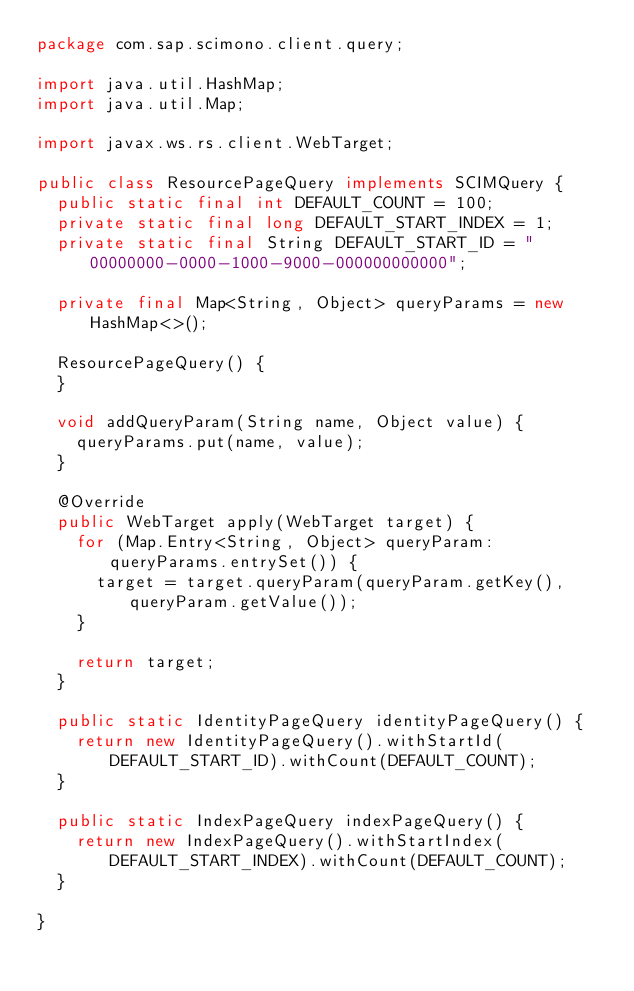<code> <loc_0><loc_0><loc_500><loc_500><_Java_>package com.sap.scimono.client.query;

import java.util.HashMap;
import java.util.Map;

import javax.ws.rs.client.WebTarget;

public class ResourcePageQuery implements SCIMQuery {
  public static final int DEFAULT_COUNT = 100;
  private static final long DEFAULT_START_INDEX = 1;
  private static final String DEFAULT_START_ID = "00000000-0000-1000-9000-000000000000";

  private final Map<String, Object> queryParams = new HashMap<>();

  ResourcePageQuery() {
  }

  void addQueryParam(String name, Object value) {
    queryParams.put(name, value);
  }

  @Override
  public WebTarget apply(WebTarget target) {
    for (Map.Entry<String, Object> queryParam: queryParams.entrySet()) {
      target = target.queryParam(queryParam.getKey(), queryParam.getValue());
    }

    return target;
  }

  public static IdentityPageQuery identityPageQuery() {
    return new IdentityPageQuery().withStartId(DEFAULT_START_ID).withCount(DEFAULT_COUNT);
  }

  public static IndexPageQuery indexPageQuery() {
    return new IndexPageQuery().withStartIndex(DEFAULT_START_INDEX).withCount(DEFAULT_COUNT);
  }

}
</code> 